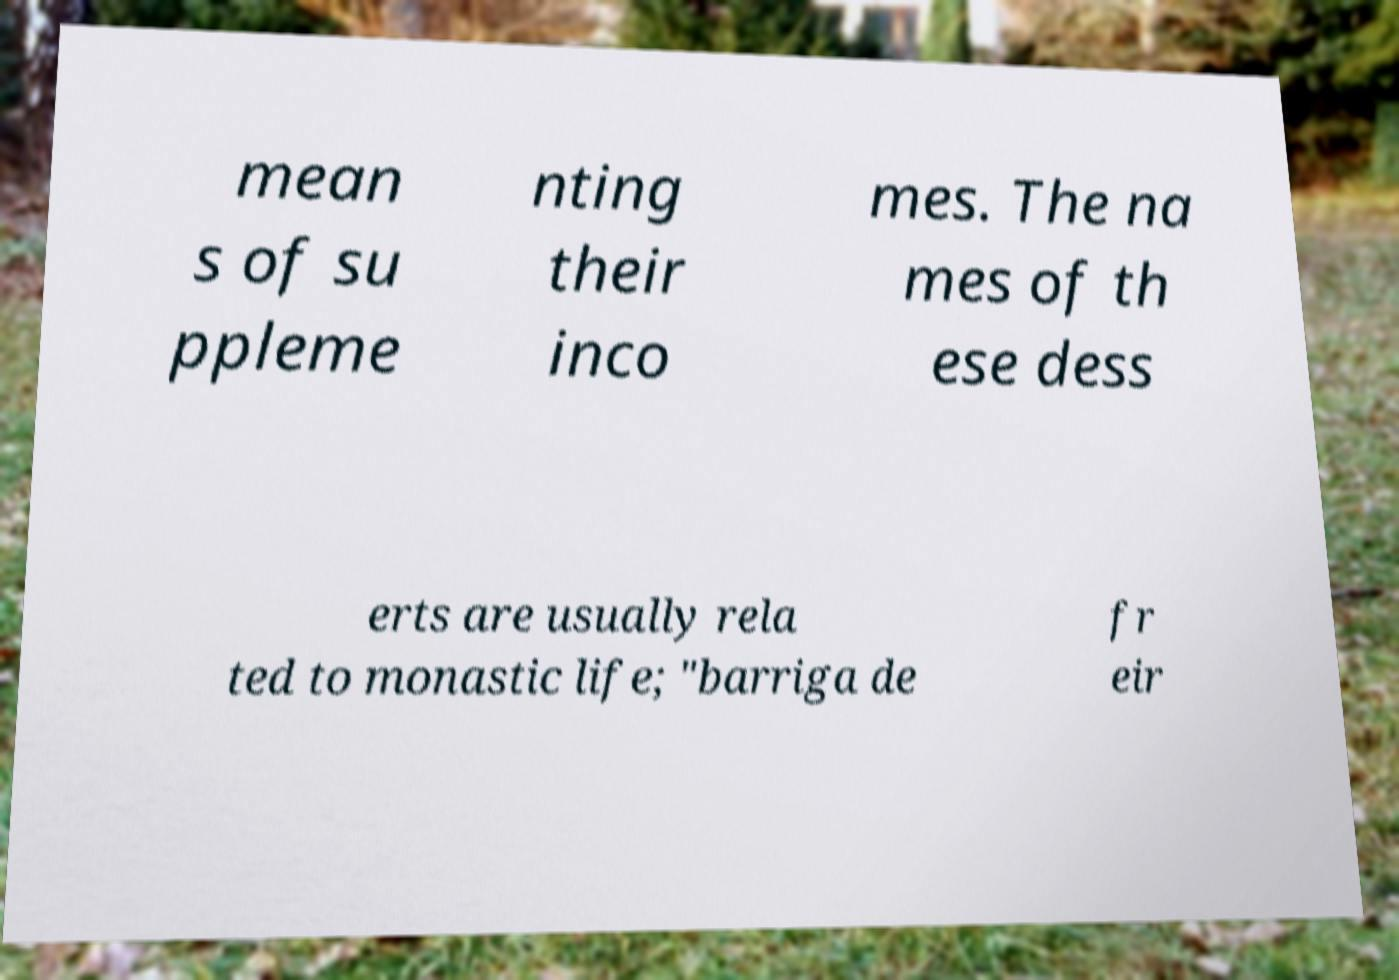Could you assist in decoding the text presented in this image and type it out clearly? mean s of su ppleme nting their inco mes. The na mes of th ese dess erts are usually rela ted to monastic life; "barriga de fr eir 